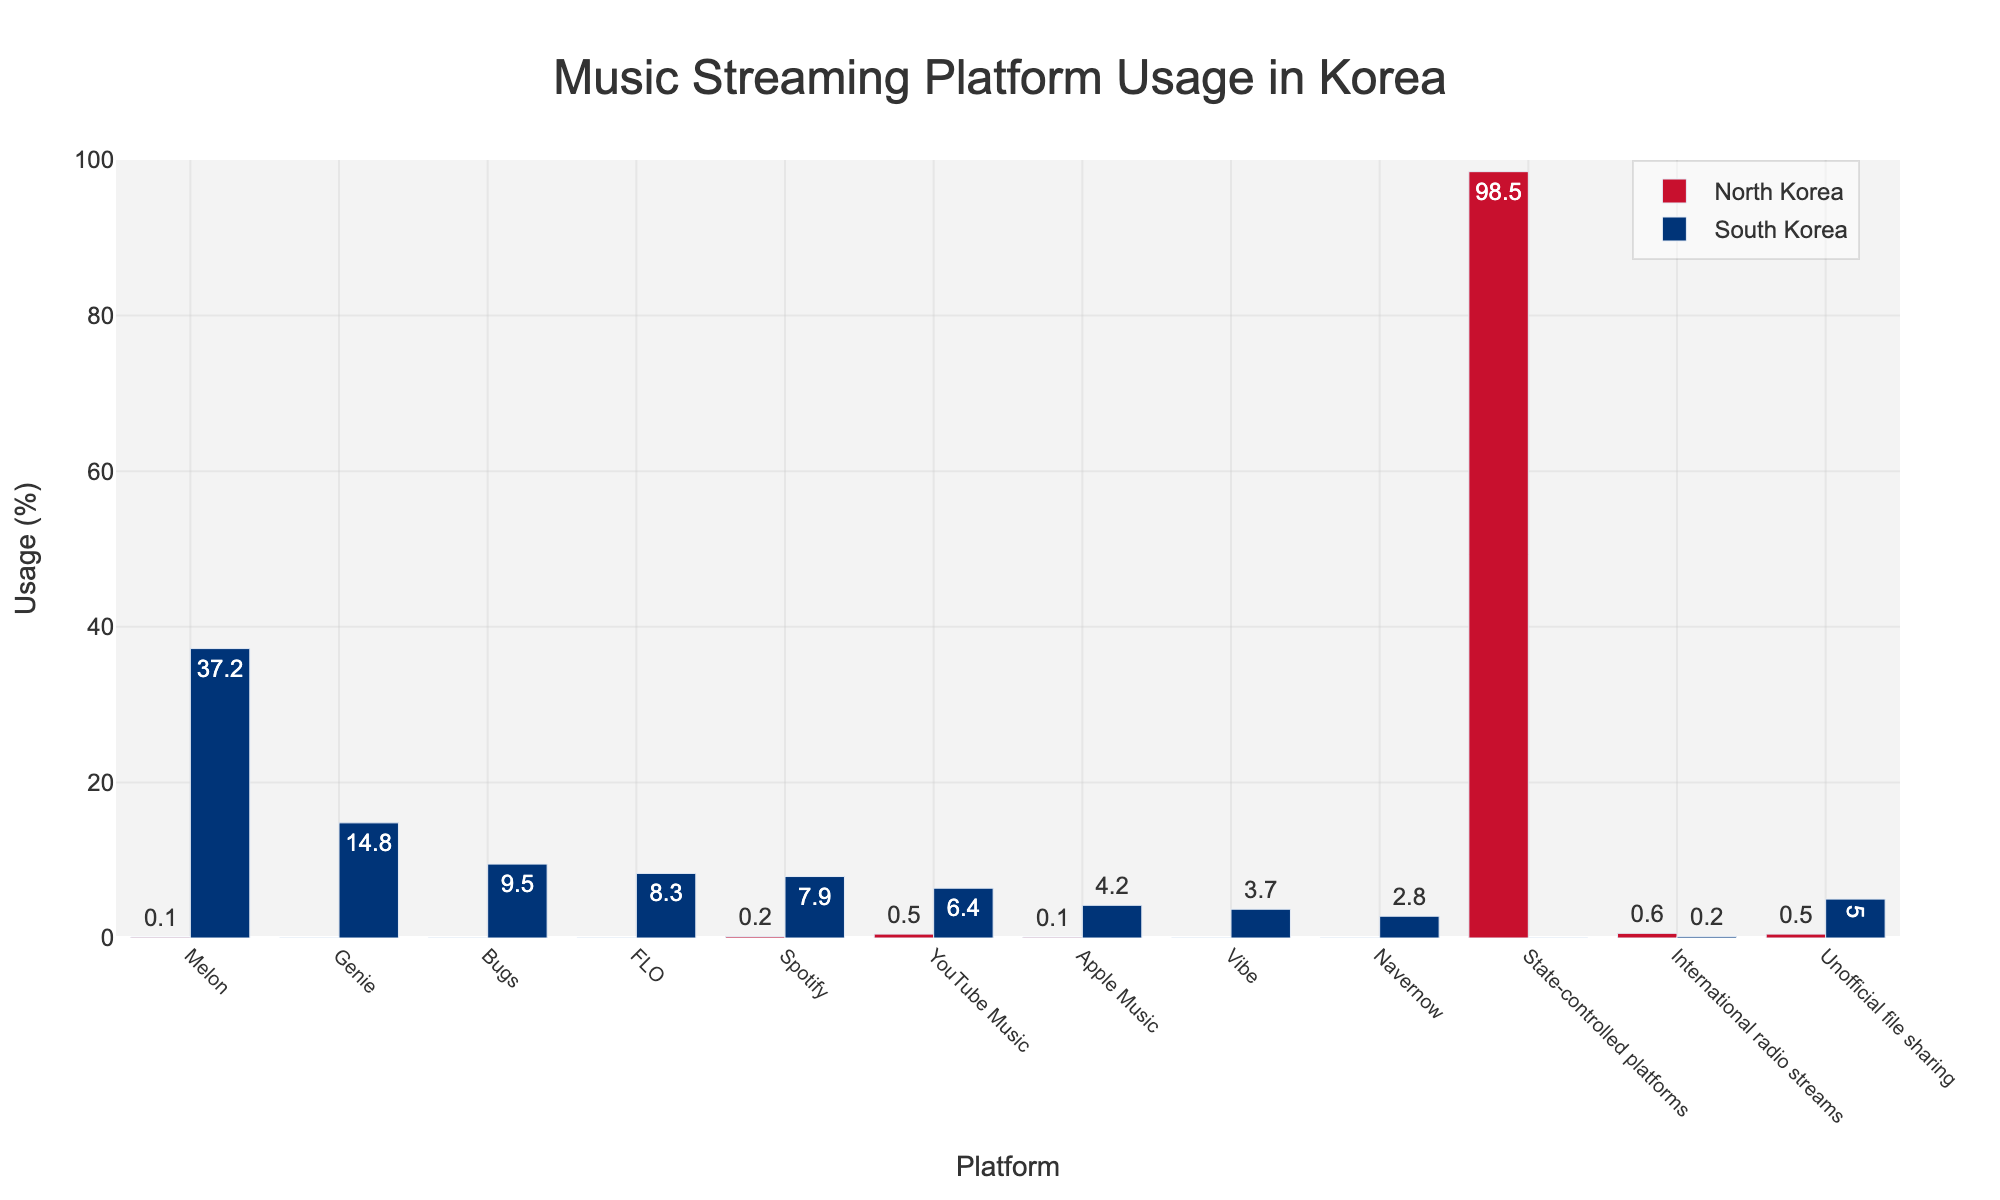Which platform has the highest usage percentage in North Korea? The bar associated with "State-controlled platforms" is the tallest among the bars for North Korea, indicating it has the highest usage.
Answer: State-controlled platforms What is the combined percentage of Spotify and YouTube Music usage in North Korea? Add the percentages for Spotify and YouTube Music in North Korea (0.2% for Spotify + 0.5% for YouTube Music).
Answer: 0.7% Which platform shows the largest difference in usage percentage between North and South Korea? Calculate the absolute differences for each platform and identify the maximum. The difference for "State-controlled platforms" is the largest (98.5% in North Korea - 0% in South Korea = 98.5%).
Answer: State-controlled platforms What is the difference in usage percentage of Melon between North Korea and South Korea? Subtract the percentage of Melon usage in North Korea from its usage in South Korea (37.2% - 0.1%).
Answer: 37.1% Which platforms are used exclusively in South Korea (i.e., not used at all in North Korea)? Identify platforms with 0% usage in North Korea and non-zero values in South Korea: Genie, Bugs, FLO, Vibe, and Navernow.
Answer: Genie, Bugs, FLO, Vibe, Navernow How does the usage percentage of unofficial file sharing compare between North and South Korea? Compare the two values: North Korea (0.5%) and South Korea (5%). South Korea's percentage is higher.
Answer: Higher in South Korea What is the average usage percentage of Melon, Genie, and Bugs in South Korea? Calculate the average of Melon (37.2%), Genie (14.8%), and Bugs (9.5%). (37.2 + 14.8 + 9.5) / 3 = 20.5%.
Answer: 20.5% Is the usage of international radio streams higher in North Korea or South Korea? Compare the two values: North Korea (0.6%) and South Korea (0.2%). North Korea's percentage is higher.
Answer: Higher in North Korea Which platform has the second highest usage percentage in South Korea? The bars show that Melon has the highest usage (37.2%), and Genie has the second highest (14.8%).
Answer: Genie Is there any usage of Apple Music in North Korea? Check the bar for Apple Music in North Korea, indicating a small value of 0.1%.
Answer: Yes 